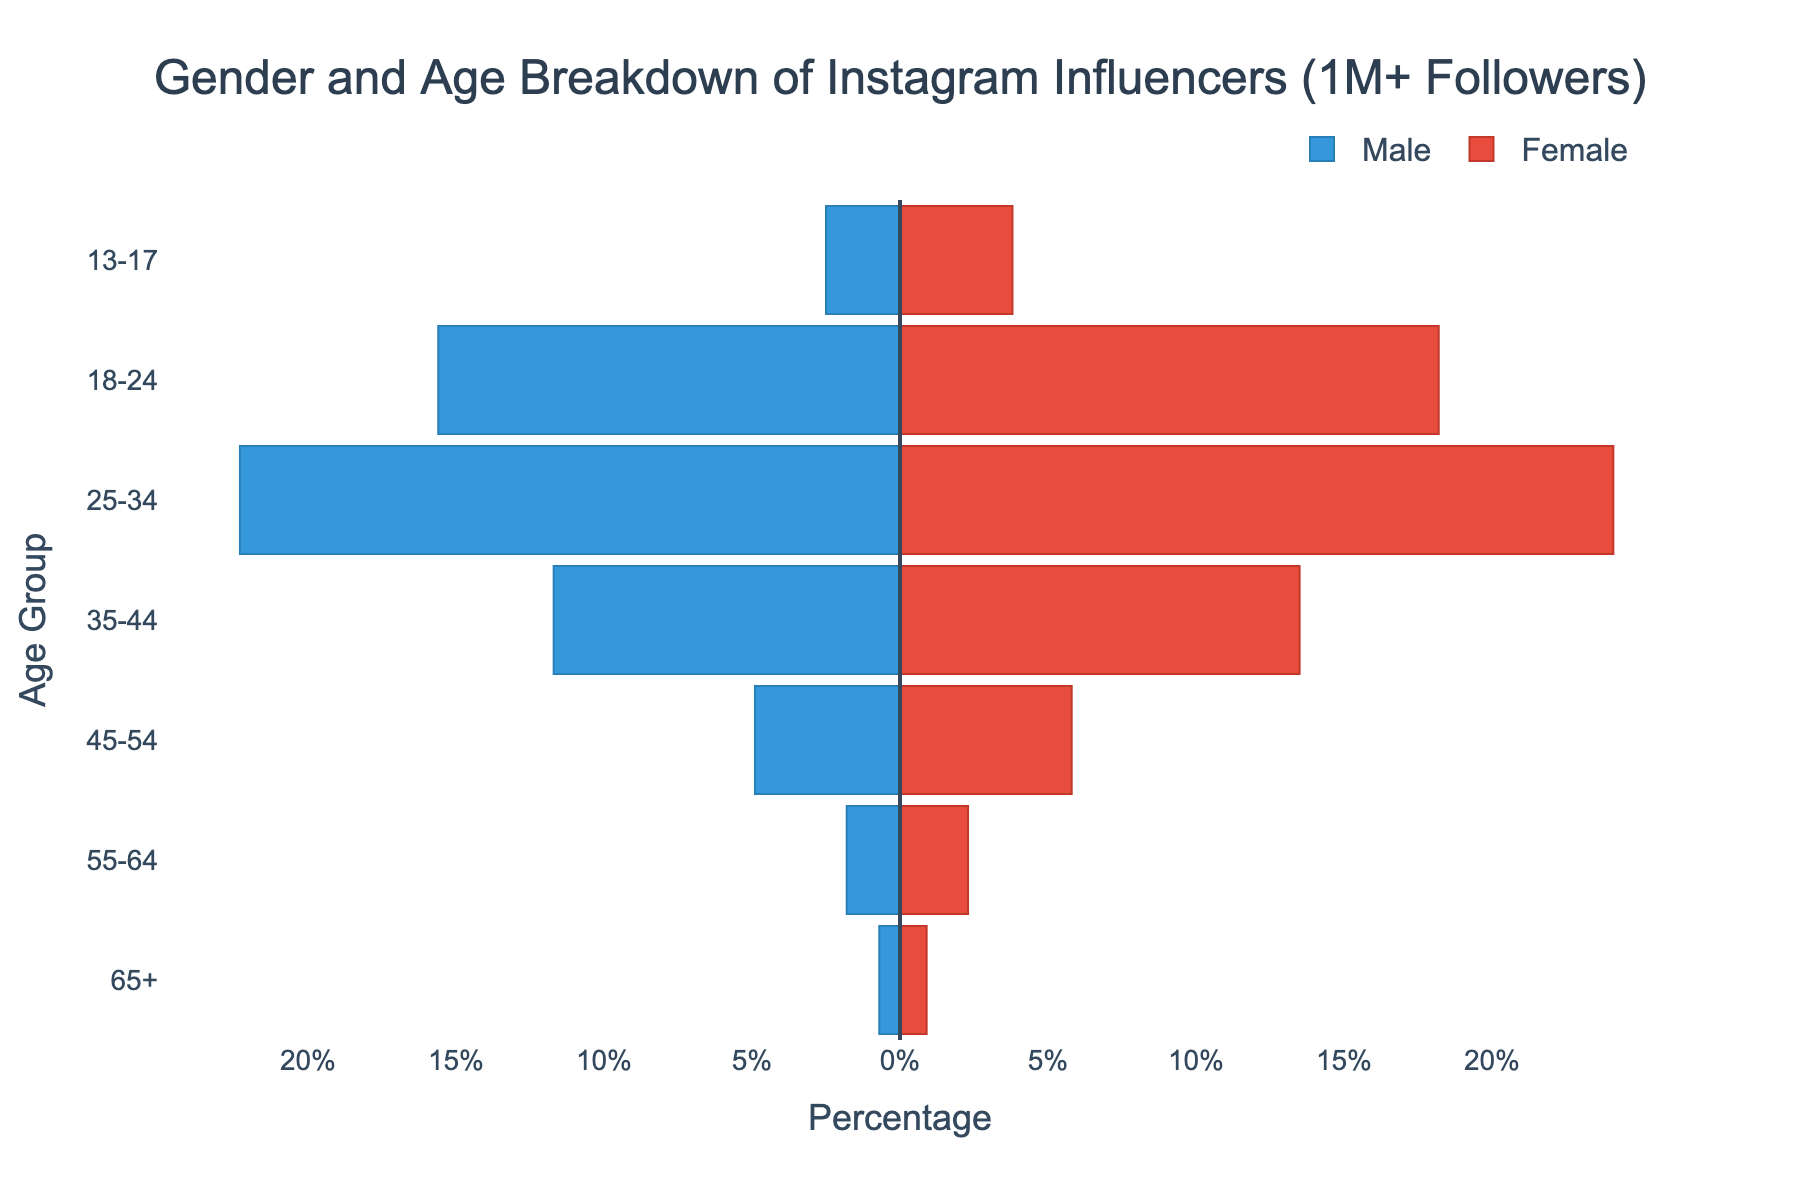How many age groups are shown in the figure? The figure categorizes Instagram influencers into different age groups. By counting the age groups on the y-axis, we determine there are 7 age groups shown.
Answer: 7 What's the title of the figure? The title of the figure is located at the top and states the general subject of the chart. It reads "Gender and Age Breakdown of Instagram Influencers (1M+ Followers)".
Answer: Gender and Age Breakdown of Instagram Influencers (1M+ Followers) Which gender has the highest percentage in the 25-34 age group? By examining the lengths of the bars for both genders in the 25-34 age group, we see that the Female bar extends further than the Male bar.
Answer: Female What is the total percentage of Male influencers in the 35-44 and 45-54 age groups combined? To find the total percentage, add the values for Male influencers in these age groups: 11.7% (35-44) + 4.9% (45-54) = 16.6%.
Answer: 16.6% Which age group has the smallest percentage of Male influencers? By looking at the length of the Male bars across all age groups, the 65+ age group has the smallest bar for Male influencers at 0.7%.
Answer: 65+ What is the total percentage of Female influencers across all age groups? Adding the Female percentages across all age groups: 3.8 + 18.2 + 24.1 + 13.5 + 5.8 + 2.3 + 0.9 = 68.6%.
Answer: 68.6% Is the percentage of Female influencers in the 18-24 age group greater than the percentage of Male influencers in the same age group? Comparatively, the Female percentage (18.2%) in the 18-24 age group is slightly higher than the Male percentage (15.6%).
Answer: Yes What is the difference in the percentage of Male and Female influencers in the 13-17 age group? Subtract the Male percentage from the Female percentage: 3.8% - 2.5% = 1.3%.
Answer: 1.3% Which age group has the highest combined percentage of Male and Female influencers? To determine this, add the percentages for each gender within each age group and compare: 
13-17: 2.5 + 3.8 = 6.3% 
18-24: 15.6 + 18.2 = 33.8% 
25-34: 22.3 + 24.1 = 46.4% 
35-44: 11.7 + 13.5 = 25.2% 
45-54: 4.9 + 5.8 = 10.7% 
55-64: 1.8 + 2.3 = 4.1% 
65+: 0.7 + 0.9 = 1.6% 
The age group 25-34 has the highest combined percentage.
Answer: 25-34 